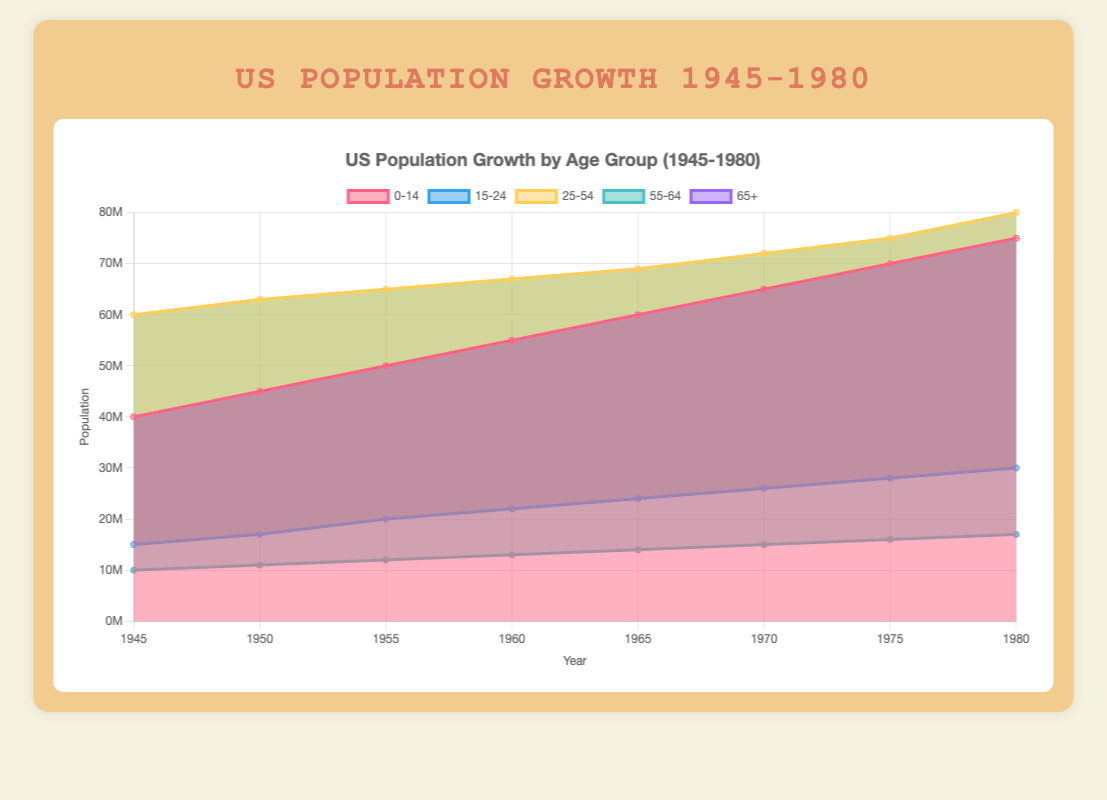What's the title of the chart? The title is displayed at the top of the chart and provides an overview of what the chart represents. In this case, it states "US Population Growth by Age Group (1945-1980)".
Answer: US Population Growth by Age Group (1945-1980) How many age groups are represented in the chart? The chart shows different colored areas, each representing a distinct age group. The legend at the top indicates there are five age groups: 0-14, 15-24, 25-54, 55-64, and 65+.
Answer: Five In which year did the age group 0-14 reach its peak population? By observing the area corresponding to the age group 0-14, the peak value is achieved in 1980.
Answer: 1980 What was the population of the 65+ age group in 1965? The area corresponding to the 65+ age group can be traced vertically to the year 1965. The population is marked in the y-axis: 14 million.
Answer: 14 million What's the sum of populations across all age groups in 1960? Sum the populations: 55 + 22 + 67 + 13 + 13 million. This totals to 55 + 22 + 67 + 13 + 13 = 170 million.
Answer: 170 million Which age group had the smallest increase in population from 1945 to 1980? By comparing the height of the areas between the years 1945 and 1980, the age group 65+ went from 10 million to 17 million, which is an increase of 7 million—the smallest among all groups.
Answer: 65+ How does the growth trend of the 15-24 age group compare to the 0-14 age group? The 15-24 age group's area increases steadily but not as dramatically as the 0-14 age group, which shows a significant rise from 1945 to 1980. The 0-14 age group grows more rapidly and consistently.
Answer: 0-14 grows faster What is the average population of the 25-54 age group over the years displayed? The population of the 25-54 group for each corresponding year summed up and then divided by the number of years: (60 + 63 + 65 + 67 + 69 + 72 + 75 + 80) / 8 = 68.875 million.
Answer: 68.875 million Which age group had the highest population in 1955? By observing the chart, the age group 25-54 has the highest area in 1955, representing around 65 million people.
Answer: 25-54 